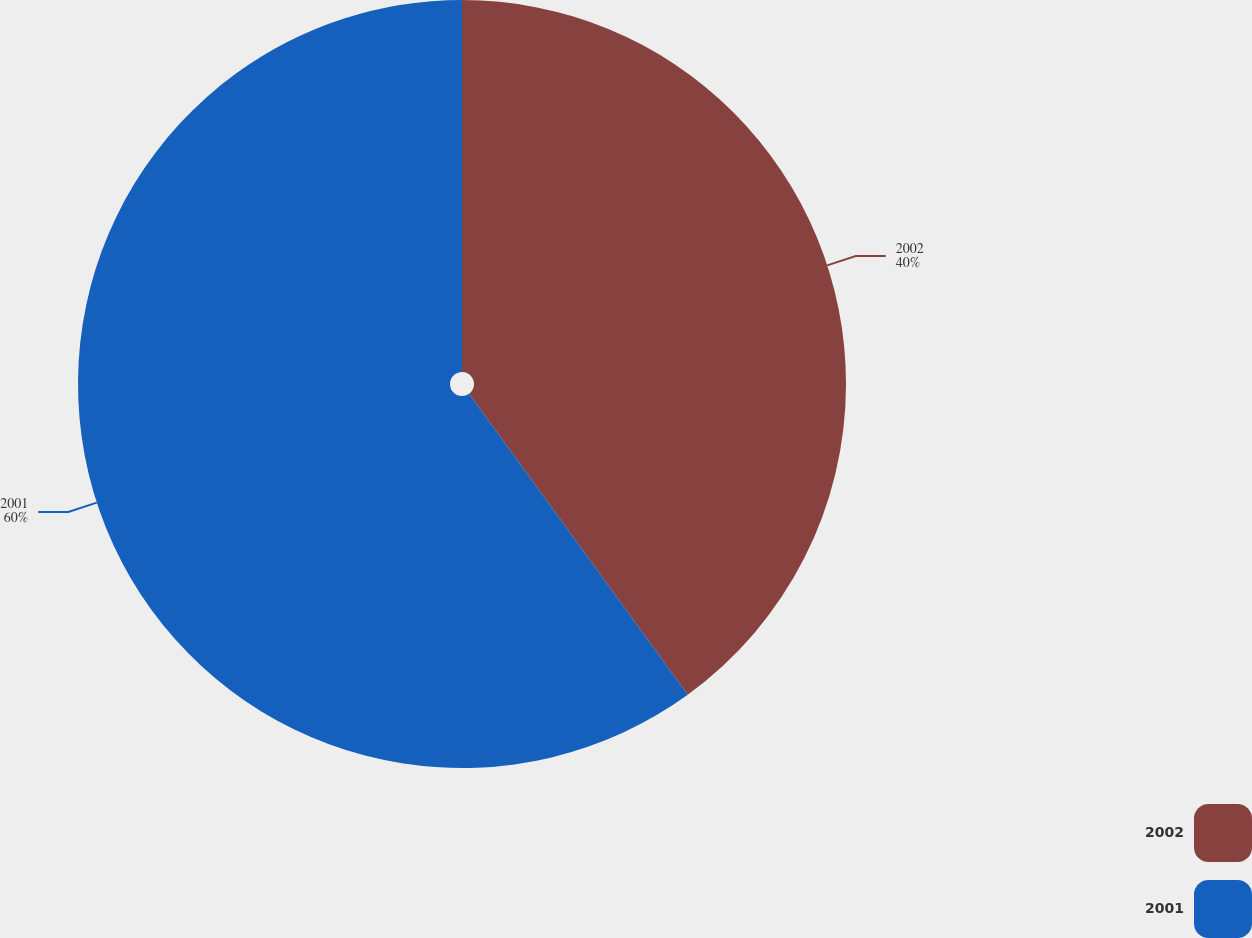<chart> <loc_0><loc_0><loc_500><loc_500><pie_chart><fcel>2002<fcel>2001<nl><fcel>40.0%<fcel>60.0%<nl></chart> 